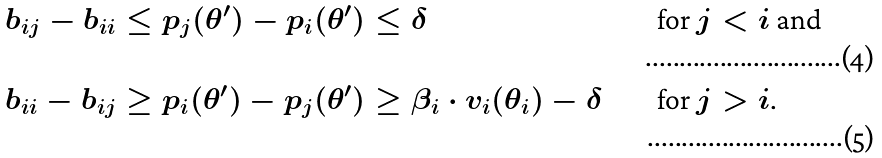<formula> <loc_0><loc_0><loc_500><loc_500>b _ { i j } - b _ { i i } & \leq p _ { j } ( \theta ^ { \prime } ) - p _ { i } ( \theta ^ { \prime } ) \leq \delta & & \text {for $j<i$ and} \\ b _ { i i } - b _ { i j } & \geq p _ { i } ( \theta ^ { \prime } ) - p _ { j } ( \theta ^ { \prime } ) \geq \beta _ { i } \cdot v _ { i } ( \theta _ { i } ) - \delta & & \text {for $j>i$.}</formula> 